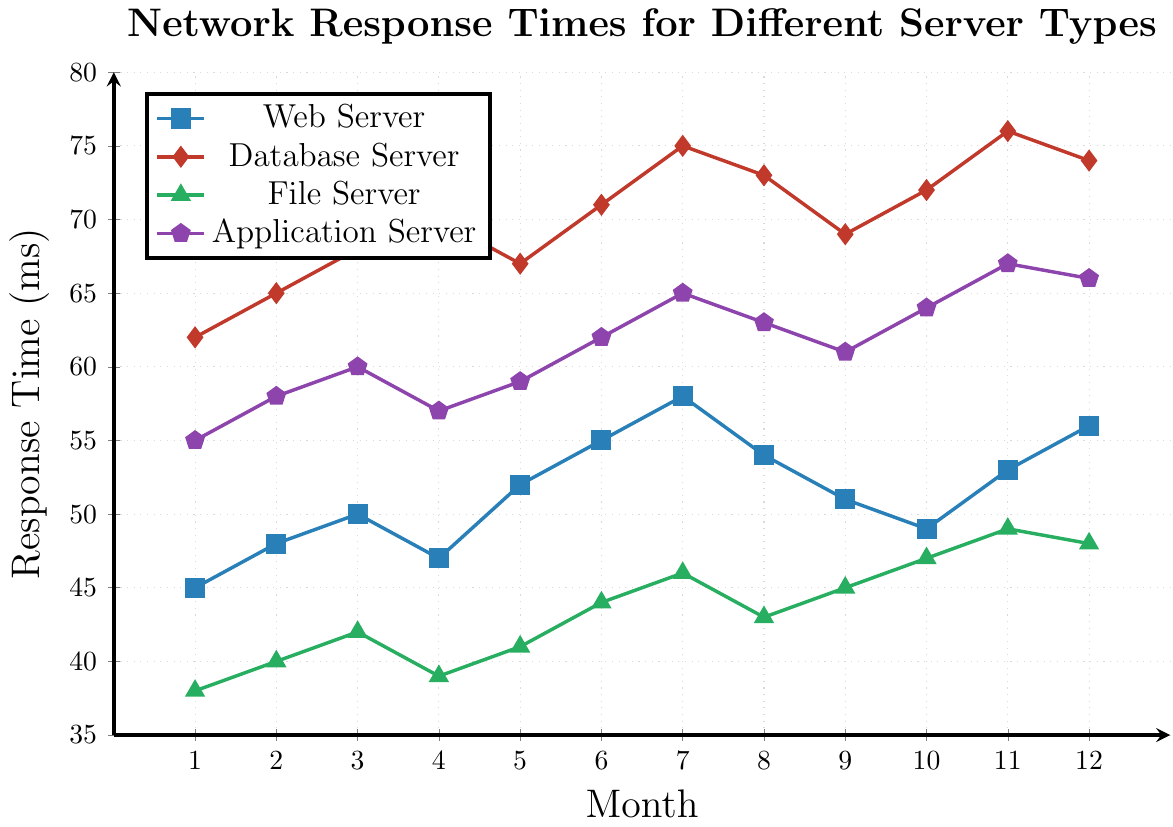Which server type has the highest average response time over the 12-month period? Calculate the average for each server type. For the Web Server: (45 + 48 + 50 + 47 + 52 + 55 + 58 + 54 + 51 + 49 + 53 + 56)/12 = 51.83 ms. For the Database Server: (62 + 65 + 68 + 70 + 67 + 71 + 75 + 73 + 69 + 72 + 76 + 74)/12 = 70.33 ms. For the File Server: (38 + 40 + 42 + 39 + 41 + 44 + 46 + 43 + 45 + 47 + 49 + 48)/12 = 43.08 ms. For the Application Server: (55 + 58 + 60 + 57 + 59 + 62 + 65 + 63 + 61 + 64 + 67 + 66)/12 = 61.08 ms. The Database Server has the highest average response time.
Answer: Database Server Which month shows the highest response time for the Web Server? Look at the values plotted for each month for the Web Server. The highest value is 58 ms in the 7th month.
Answer: Month 7 During which month did the File Server experience the lowest response time? Look at the plotted values for each month for the File Server. The lowest value is 38 ms in the 1st month.
Answer: Month 1 How does the response time of the Application Server in month 6 compare to the Database Server in the same month? In month 6, the Application Server's response time is 62 ms, and the Database Server's is 71 ms. The Application Server has a lower response time.
Answer: Lower Between which two consecutive months did the Database Server show the largest increase in response time? Look at the differences between consecutive months for the Database Server. The largest increase is between month 10 (72 ms) and month 11 (76 ms), with an increase of 4 ms.
Answer: Between months 10 and 11 What is the combined response time for the File Server and Web Server in month 9? Add the response times for the File Server (45 ms) and Web Server (51 ms) in month 9: 45 + 51 = 96 ms.
Answer: 96 ms Which server type consistently shows the lowest response times across all months? Compare the response times across all months for each server type. The File Server, with values mostly in the 40s, so consistently has the lowest response times.
Answer: File Server What color is used to represent the Application Server response times in the plot? Look at the legend to find the color associated with the Application Server, which is marked in purple.
Answer: Purple In which month does the Web Server have its second highest response time? Observe the values for the Web Server. The highest is 58 ms in month 7, and the second highest is 56 ms in month 12.
Answer: Month 12 If we wanted to improve performance, which server type would be the highest priority based on average response times? The Database Server has the highest average response time (70.33 ms), thus should be the highest priority for performance improvement.
Answer: Database Server 